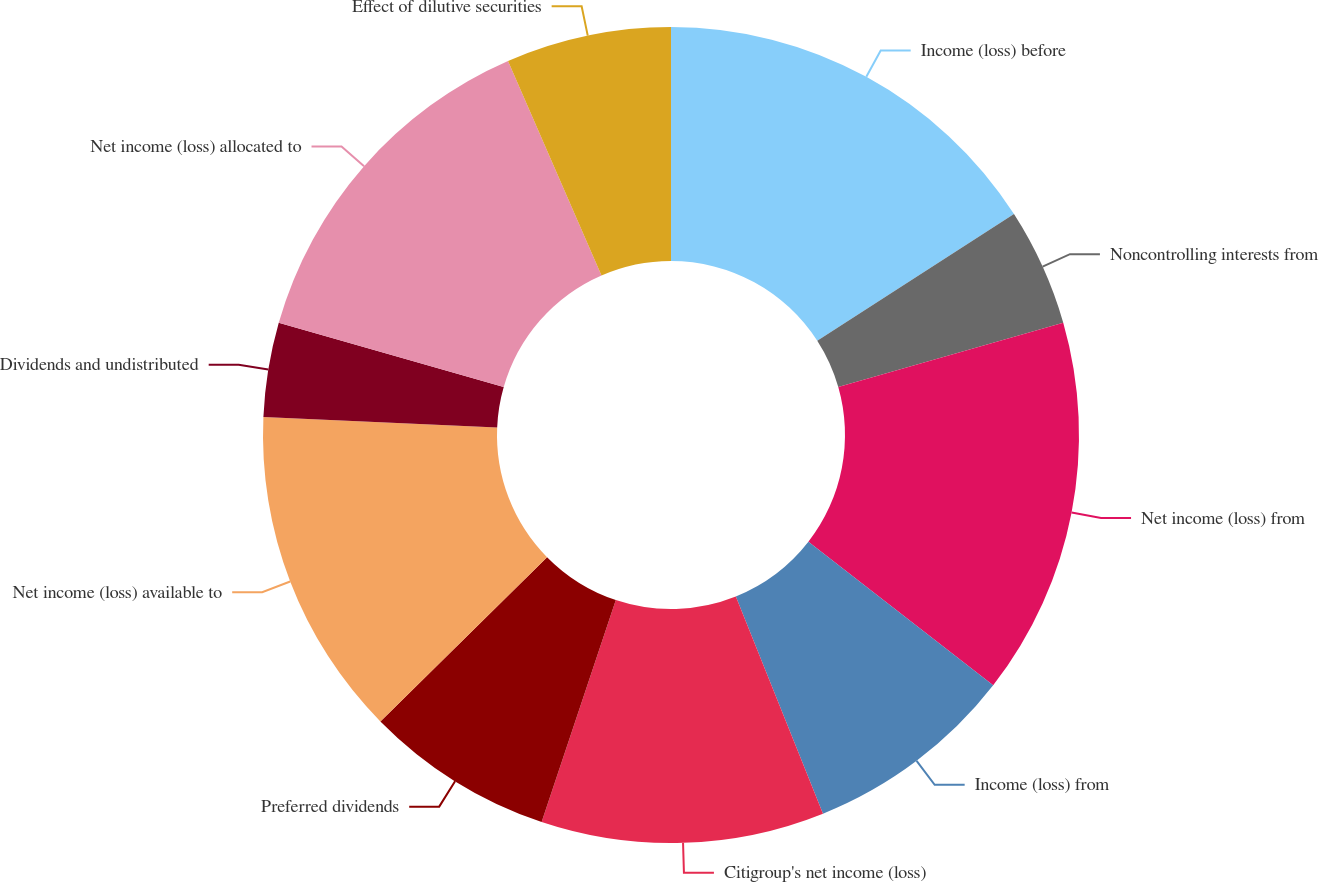Convert chart. <chart><loc_0><loc_0><loc_500><loc_500><pie_chart><fcel>Income (loss) before<fcel>Noncontrolling interests from<fcel>Net income (loss) from<fcel>Income (loss) from<fcel>Citigroup's net income (loss)<fcel>Preferred dividends<fcel>Net income (loss) available to<fcel>Dividends and undistributed<fcel>Net income (loss) allocated to<fcel>Effect of dilutive securities<nl><fcel>15.89%<fcel>4.67%<fcel>14.95%<fcel>8.41%<fcel>11.21%<fcel>7.48%<fcel>13.08%<fcel>3.74%<fcel>14.02%<fcel>6.54%<nl></chart> 